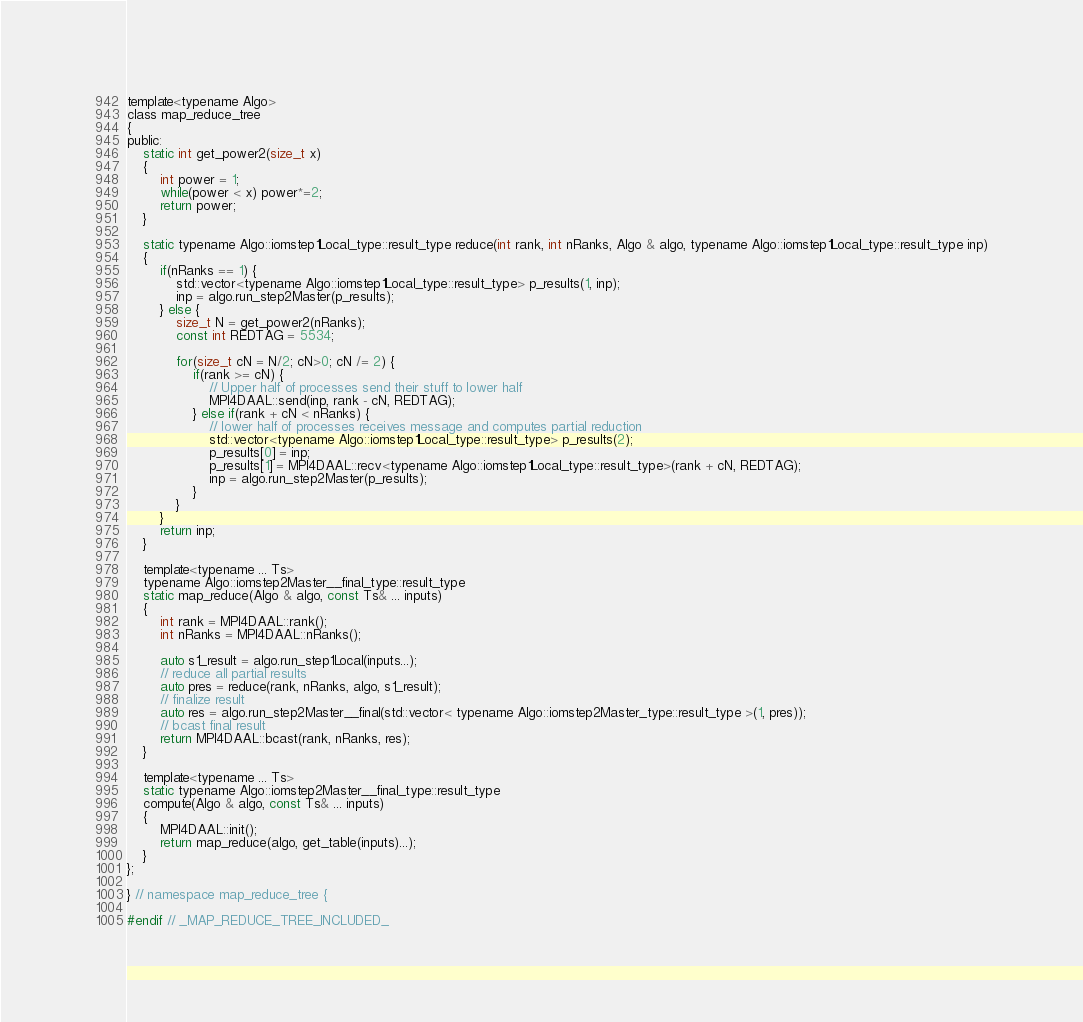<code> <loc_0><loc_0><loc_500><loc_500><_C_>
template<typename Algo>
class map_reduce_tree
{
public:
    static int get_power2(size_t x)
    {
        int power = 1;
        while(power < x) power*=2;
        return power;
    }

    static typename Algo::iomstep1Local_type::result_type reduce(int rank, int nRanks, Algo & algo, typename Algo::iomstep1Local_type::result_type inp)
    {
        if(nRanks == 1) {
            std::vector<typename Algo::iomstep1Local_type::result_type> p_results(1, inp);
            inp = algo.run_step2Master(p_results);
        } else {
            size_t N = get_power2(nRanks);
            const int REDTAG = 5534;
            
            for(size_t cN = N/2; cN>0; cN /= 2) {
                if(rank >= cN) {
                    // Upper half of processes send their stuff to lower half
                    MPI4DAAL::send(inp, rank - cN, REDTAG);
                } else if(rank + cN < nRanks) {
                    // lower half of processes receives message and computes partial reduction
                    std::vector<typename Algo::iomstep1Local_type::result_type> p_results(2);
                    p_results[0] = inp;
                    p_results[1] = MPI4DAAL::recv<typename Algo::iomstep1Local_type::result_type>(rank + cN, REDTAG);
                    inp = algo.run_step2Master(p_results);
                }
            }
        }
        return inp;
    }

    template<typename ... Ts>
    typename Algo::iomstep2Master__final_type::result_type
    static map_reduce(Algo & algo, const Ts& ... inputs)
    {
        int rank = MPI4DAAL::rank();
        int nRanks = MPI4DAAL::nRanks();

        auto s1_result = algo.run_step1Local(inputs...);
        // reduce all partial results
        auto pres = reduce(rank, nRanks, algo, s1_result);
        // finalize result
        auto res = algo.run_step2Master__final(std::vector< typename Algo::iomstep2Master_type::result_type >(1, pres));
        // bcast final result
        return MPI4DAAL::bcast(rank, nRanks, res);
    }

    template<typename ... Ts>
    static typename Algo::iomstep2Master__final_type::result_type
    compute(Algo & algo, const Ts& ... inputs)
    {
        MPI4DAAL::init();
        return map_reduce(algo, get_table(inputs)...);
    }
};

} // namespace map_reduce_tree {

#endif // _MAP_REDUCE_TREE_INCLUDED_
</code> 